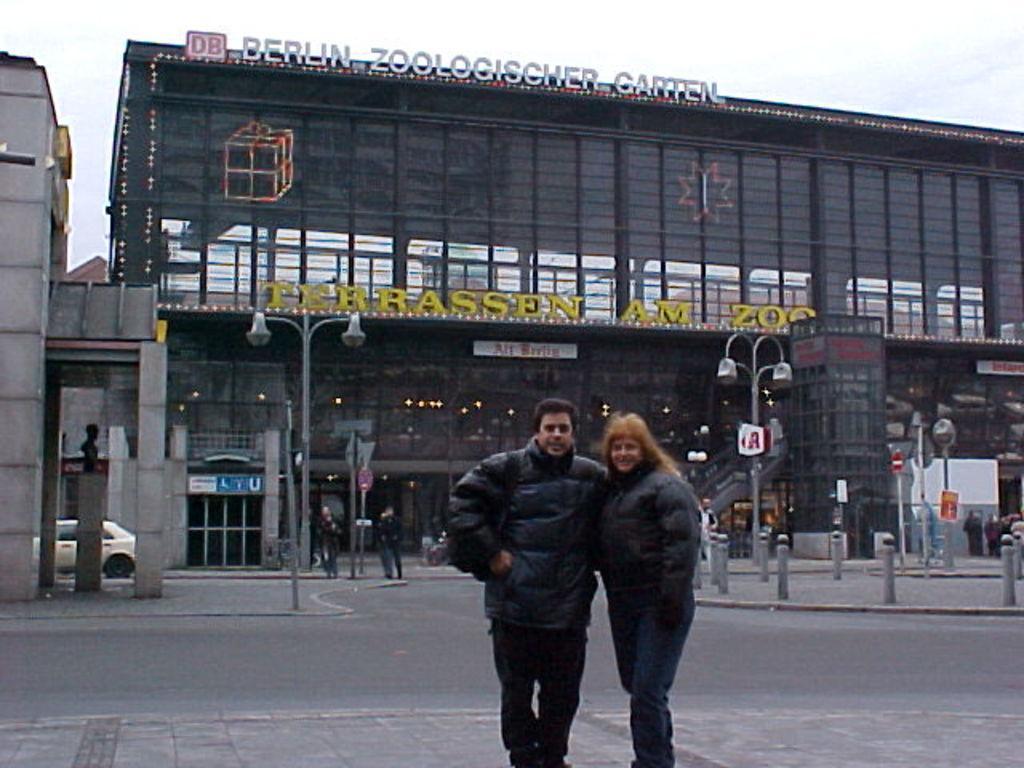In one or two sentences, can you explain what this image depicts? There are two persons on the platform and there is a vehicle on the road. Here we can see poles, lights, boards and buildings. In the background there is sky. 